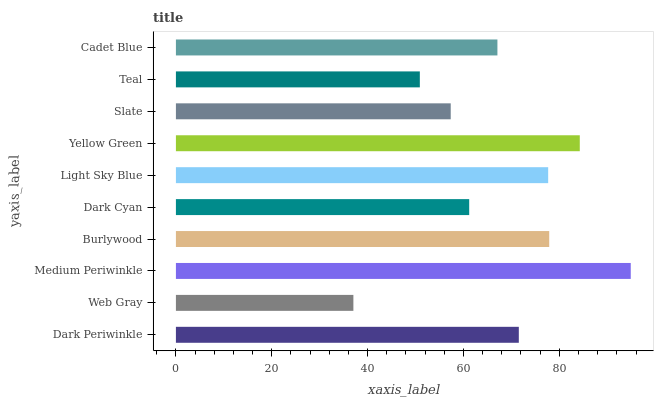Is Web Gray the minimum?
Answer yes or no. Yes. Is Medium Periwinkle the maximum?
Answer yes or no. Yes. Is Medium Periwinkle the minimum?
Answer yes or no. No. Is Web Gray the maximum?
Answer yes or no. No. Is Medium Periwinkle greater than Web Gray?
Answer yes or no. Yes. Is Web Gray less than Medium Periwinkle?
Answer yes or no. Yes. Is Web Gray greater than Medium Periwinkle?
Answer yes or no. No. Is Medium Periwinkle less than Web Gray?
Answer yes or no. No. Is Dark Periwinkle the high median?
Answer yes or no. Yes. Is Cadet Blue the low median?
Answer yes or no. Yes. Is Medium Periwinkle the high median?
Answer yes or no. No. Is Light Sky Blue the low median?
Answer yes or no. No. 